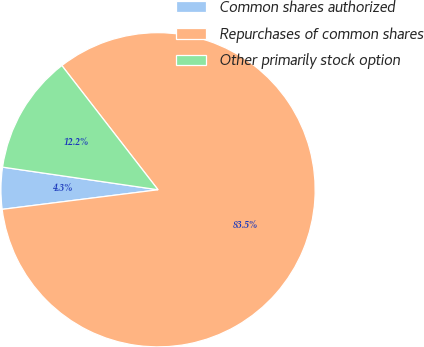Convert chart. <chart><loc_0><loc_0><loc_500><loc_500><pie_chart><fcel>Common shares authorized<fcel>Repurchases of common shares<fcel>Other primarily stock option<nl><fcel>4.29%<fcel>83.49%<fcel>12.21%<nl></chart> 